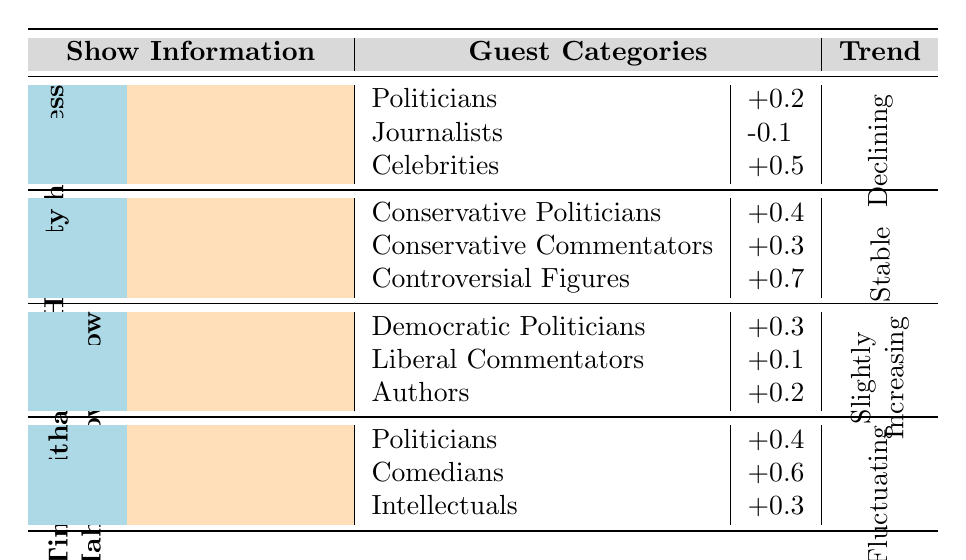What is the overall rating trend of "The Rachel Maddow Show"? The table indicates that the overall rating trend for "The Rachel Maddow Show" is described as "Slightly Increasing."
Answer: Slightly Increasing Which category of guests on "Hannity" has the highest average rating impact? The table shows that the "Controversial Figures" category on "Hannity" has the highest average rating impact at +0.7.
Answer: Controversial Figures What is the average rating impact of celebrity guests on "Meet the Press"? According to the table, the average rating impact of celebrity guests on "Meet the Press" is +0.5.
Answer: +0.5 Are ratings for "Real Time with Bill Maher" increasing, decreasing, or fluctuating? The overall rating trend for "Real Time with Bill Maher" is noted as "Fluctuating," indicating variability in ratings.
Answer: Fluctuating What is the combined average rating impact of all guest categories on "The Rachel Maddow Show"? The average rating impacts for the categories are +0.3 (Democratic Politicians), +0.1 (Liberal Commentators), and +0.2 (Authors). Summing these gives +0.3 + 0.1 + 0.2 = +0.6.
Answer: +0.6 Which network hosts "Meet the Press"? The table specifies that "Meet the Press" is hosted on NBC.
Answer: NBC How does the average rating impact of journalists compare across all shows? Looking at the table, "Meet the Press" shows a -0.1 impact from journalists, while other shows do not list a journalists category, making it lower than any applicable metric.
Answer: -0.1 If "Controversial Figures" increase guest appearances on "Hannity," what is the expected impact on ratings? The table indicates that the average rating impact of "Controversial Figures" is +0.7, so an increase would likely raise the overall ratings positively.
Answer: Expected impact is positive What is the difference in average rating impact between politicians and comedians on "Real Time with Bill Maher"? From the table, the impact for politicians is +0.4 and for comedians is +0.6. The difference is +0.6 - +0.4 = +0.2.
Answer: +0.2 Which show has the lowest impact from journalists? The only show that lists an impact from journalists is "Meet the Press," with an impact of -0.1, making it the lowest.
Answer: Meet the Press 